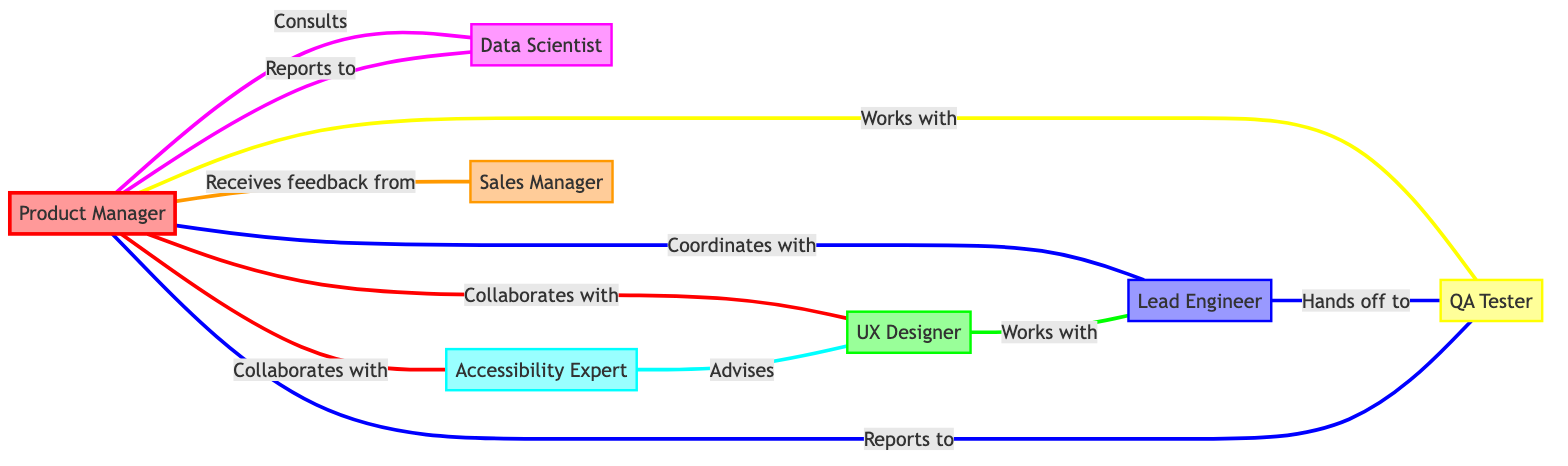What is the role of node PM001? Node PM001 represents the Product Manager, who oversees product development and ensures inclusivity.
Answer: Oversees product development and ensures inclusivity How many nodes are there in the diagram? The diagram includes a total of 7 nodes: Product Manager, UX Designer, Lead Engineer, QA Tester, Data Scientist, Accessibility Expert, and Sales Manager.
Answer: 7 Which node does the QA Tester report to? The QA Tester (QA001) reports to the Product Manager (PM001). This is observed by following the link labeled "Reports to" from QA001.
Answer: Product Manager What type of relationship exists between the UX Designer and the Lead Engineer? The relationship between the UX Designer (UX001) and the Lead Engineer (ENG001) is indicated by the link labeled "Works with," which signifies collaboration on design implementation.
Answer: Works with Who provides feedback to the Product Manager? The Sales Manager (SALES001) provides feedback to the Product Manager (PM001), as indicated by the "Receives feedback from" link.
Answer: Sales Manager How many types of relationships are depicted in the diagram? The diagram includes multiple types of relationships: Collaborates with, Coordinates with, Works with, Consults, Receives feedback from, Advised, Hands off to, and Reports to. In total, there are 7 different types of relationships.
Answer: 7 Which roles does the Accessibility Expert advise? The Accessibility Expert (ACC001) advises the UX Designer (UX001) to ensure that designs meet accessibility standards, as shown in the directed link labeled "Advises."
Answer: UX Designer What is the main purpose of the Data Scientist in the diagram? The Data Scientist (DATA001) analyzes user data to inform decisions and presents data insights and trends, which is conveyed through its reporting relationship with the Product Manager and its consulting role.
Answer: Analyzes user data to inform decisions What is the direct link type between the Lead Engineer and the QA Tester? The direct link type between the Lead Engineer (ENG001) and the QA Tester (QA001) is "Hands off to," indicating the transfer of builds for testing from engineering to quality assurance.
Answer: Hands off to 